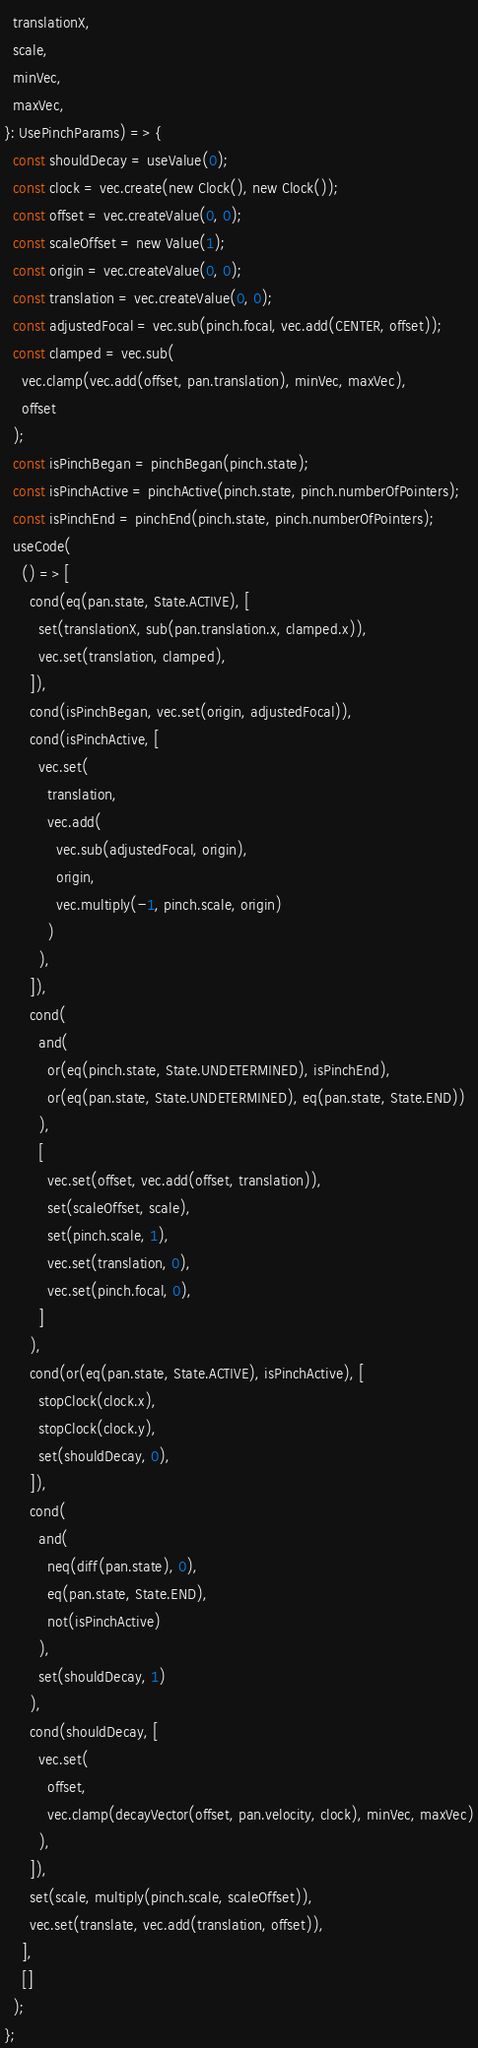<code> <loc_0><loc_0><loc_500><loc_500><_TypeScript_>  translationX,
  scale,
  minVec,
  maxVec,
}: UsePinchParams) => {
  const shouldDecay = useValue(0);
  const clock = vec.create(new Clock(), new Clock());
  const offset = vec.createValue(0, 0);
  const scaleOffset = new Value(1);
  const origin = vec.createValue(0, 0);
  const translation = vec.createValue(0, 0);
  const adjustedFocal = vec.sub(pinch.focal, vec.add(CENTER, offset));
  const clamped = vec.sub(
    vec.clamp(vec.add(offset, pan.translation), minVec, maxVec),
    offset
  );
  const isPinchBegan = pinchBegan(pinch.state);
  const isPinchActive = pinchActive(pinch.state, pinch.numberOfPointers);
  const isPinchEnd = pinchEnd(pinch.state, pinch.numberOfPointers);
  useCode(
    () => [
      cond(eq(pan.state, State.ACTIVE), [
        set(translationX, sub(pan.translation.x, clamped.x)),
        vec.set(translation, clamped),
      ]),
      cond(isPinchBegan, vec.set(origin, adjustedFocal)),
      cond(isPinchActive, [
        vec.set(
          translation,
          vec.add(
            vec.sub(adjustedFocal, origin),
            origin,
            vec.multiply(-1, pinch.scale, origin)
          )
        ),
      ]),
      cond(
        and(
          or(eq(pinch.state, State.UNDETERMINED), isPinchEnd),
          or(eq(pan.state, State.UNDETERMINED), eq(pan.state, State.END))
        ),
        [
          vec.set(offset, vec.add(offset, translation)),
          set(scaleOffset, scale),
          set(pinch.scale, 1),
          vec.set(translation, 0),
          vec.set(pinch.focal, 0),
        ]
      ),
      cond(or(eq(pan.state, State.ACTIVE), isPinchActive), [
        stopClock(clock.x),
        stopClock(clock.y),
        set(shouldDecay, 0),
      ]),
      cond(
        and(
          neq(diff(pan.state), 0),
          eq(pan.state, State.END),
          not(isPinchActive)
        ),
        set(shouldDecay, 1)
      ),
      cond(shouldDecay, [
        vec.set(
          offset,
          vec.clamp(decayVector(offset, pan.velocity, clock), minVec, maxVec)
        ),
      ]),
      set(scale, multiply(pinch.scale, scaleOffset)),
      vec.set(translate, vec.add(translation, offset)),
    ],
    []
  );
};
</code> 